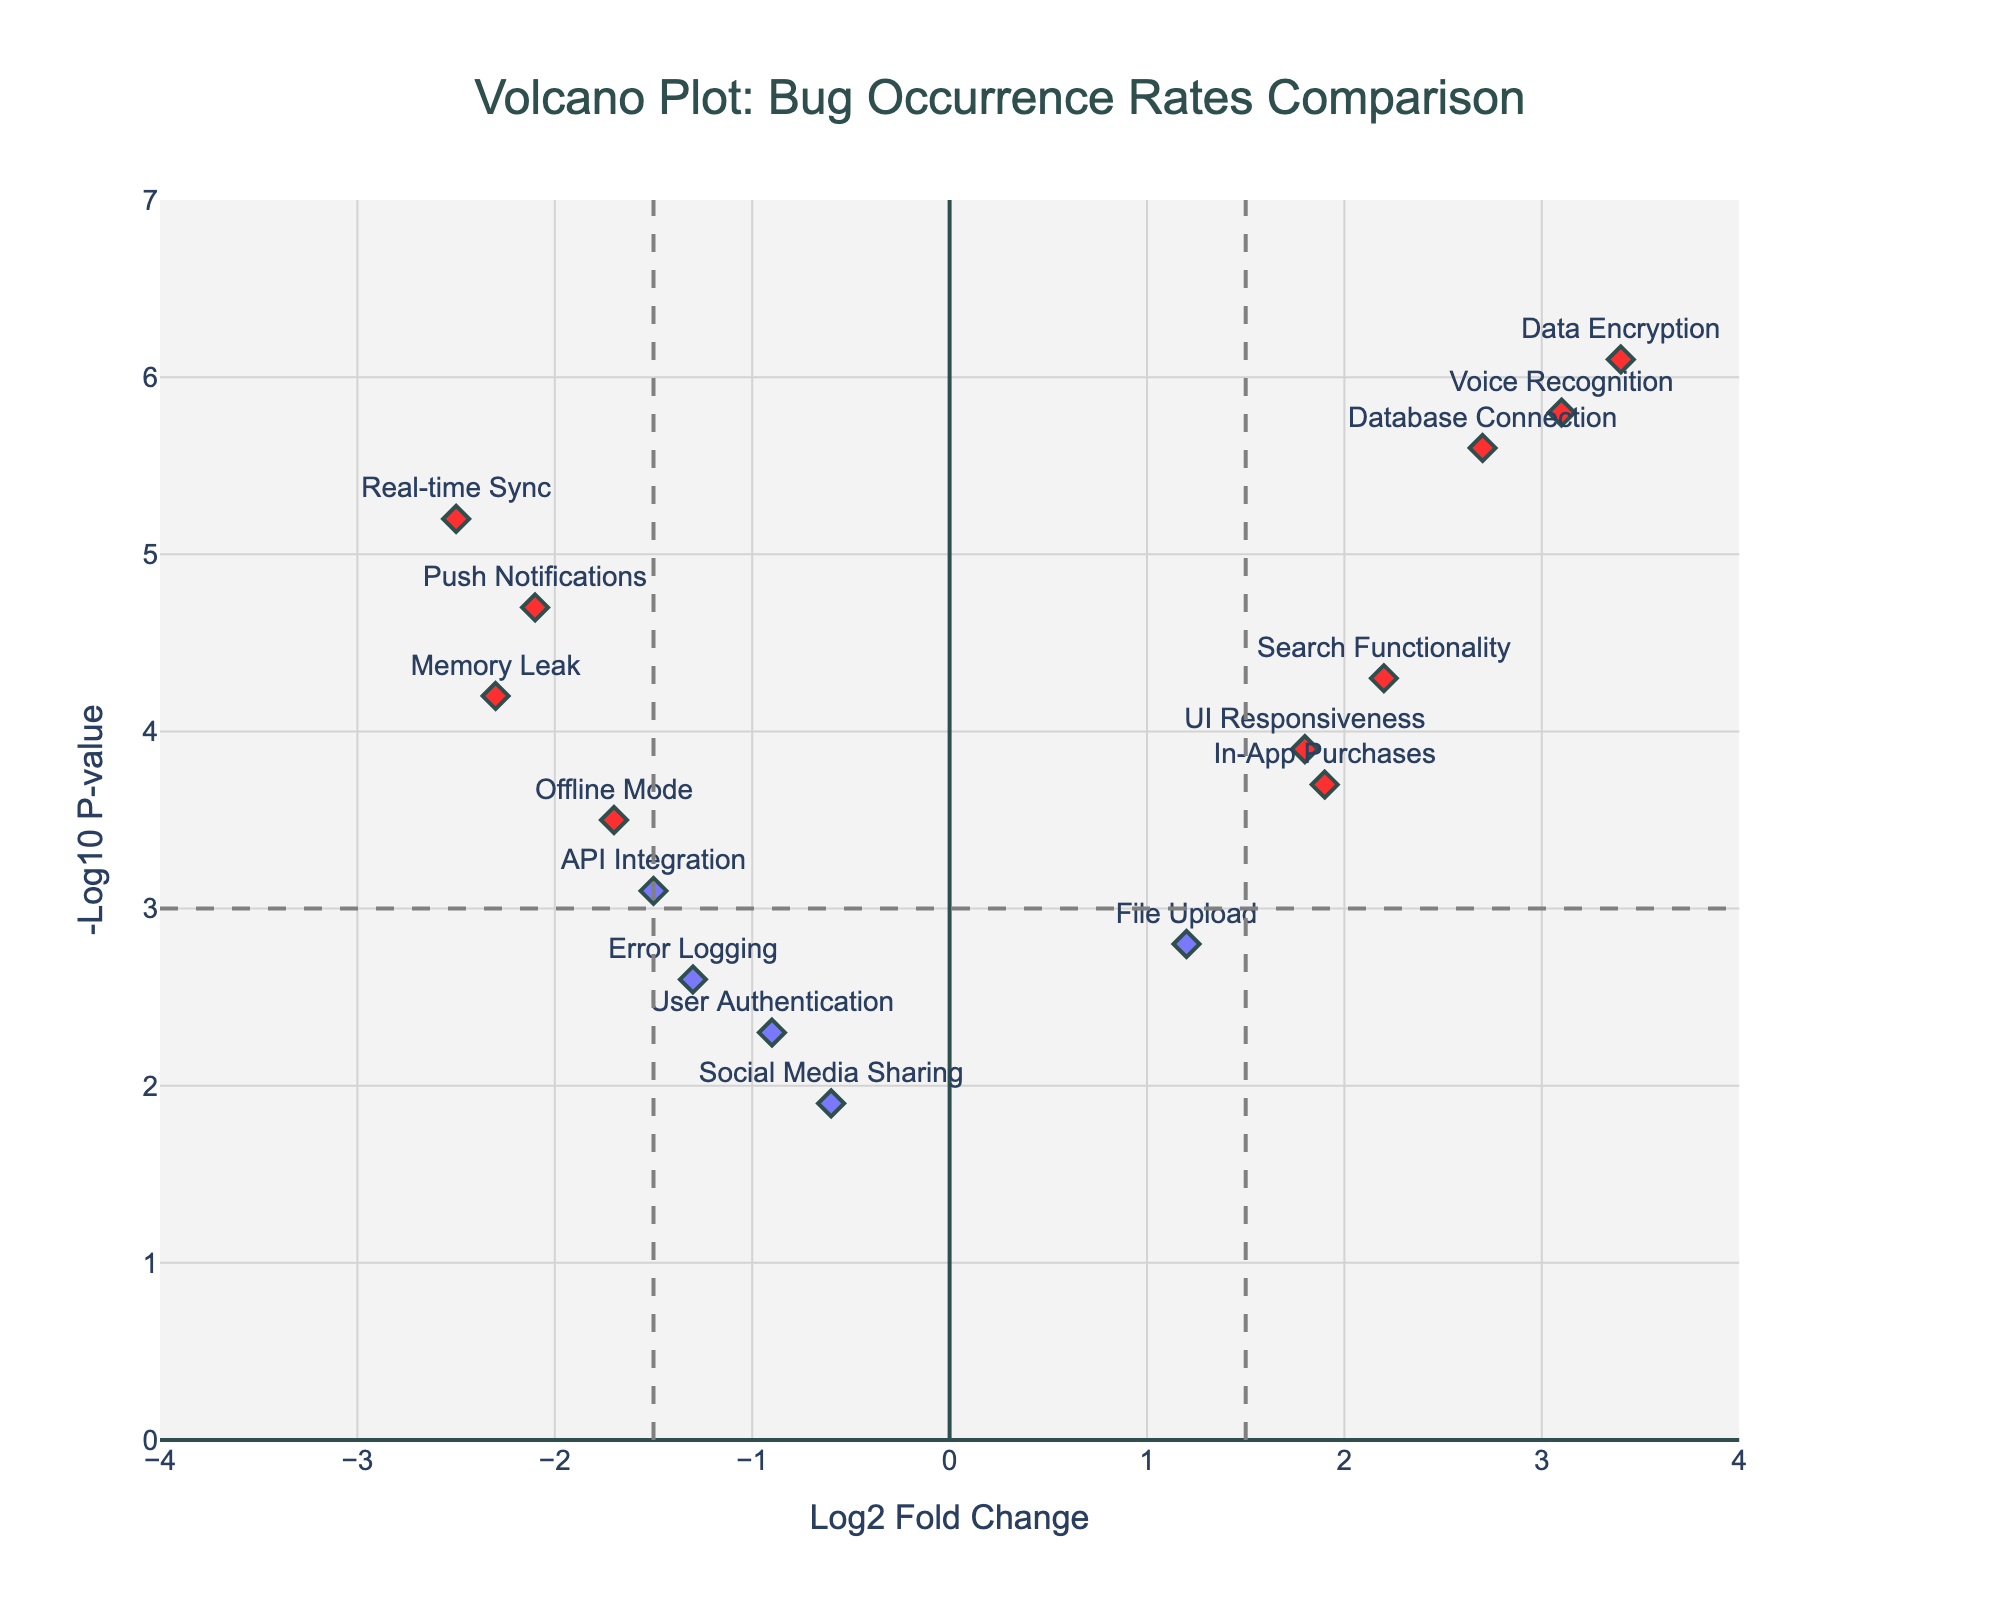What is the title of the plot? The title of the plot can be found at the top of the figure, which is centered and shown in a larger and dark slate grey font.
Answer: Volcano Plot: Bug Occurrence Rates Comparison How many features lie above the significance threshold on the y-axis? The significance threshold on the y-axis is indicated by a horizontal dashed grey line at -Log10 P-value = 3. By counting the number of markers above this line, we find there are 10 features.
Answer: 10 What feature is represented by the data point with the highest negLogPvalue? The highest -Log10 P-value is represented by the feature "Data Encryption" as indicated by the topmost data point at around y = 6.1.
Answer: Data Encryption Which feature has the most significant increase in bug occurrence rate? The feature with the highest positive log2 fold change indicates the most significant increase in bug occurrence rate. "Data Encryption" has the highest log2 fold change at approximately 3.4.
Answer: Data Encryption Which feature has both a significant log2 fold change and a significant negLogPvalue? A significant log2 fold change is above the thresholds of ±1.5 and a significant negLogPvalue is above 3. Features that meet these criteria are highlighted in red. These are Memory Leak, UI Responsiveness, Database Connection, Push Notifications, Data Encryption, Voice Recognition, Real-time Sync, and Search Functionality.
Answer: 8 features Which feature has the most significant decrease in bug occurrence rate? The most significant decrease in bug occurrence rate is represented by the feature with the lowest log2 fold change. Memory Leak shows the lowest log2 fold change at about -2.3.
Answer: Memory Leak What relationship exists between the log2 fold change and -Log10 P-value thresholds? The log2 fold change thresholds (±1.5) are represented by vertical dashed grey lines, and the -Log10 P-value threshold (3) is indicated by the horizontal dashed grey line. Features beyond these thresholds in both directions are highlighted in red.
Answer: Significant values exceed the thresholds How does the log2 fold change for Voice Recognition compare to that for Real-time Sync? Voice Recognition has a log2 fold change of about 3.1, which is higher than the log2 fold change for Real-time Sync at around -2.5.
Answer: Voice Recognition is greater What can you infer about the consistency of feature performance across versions based on this plot? Features with similar log2 fold changes and significant -Log10 P-values suggest consistent performance. Features scattered widely suggest varying performance across versions. Most features differ significantly in log2 fold change and have high -Log10 P-values, indicating inconsistent performance.
Answer: Inconsistent performance 